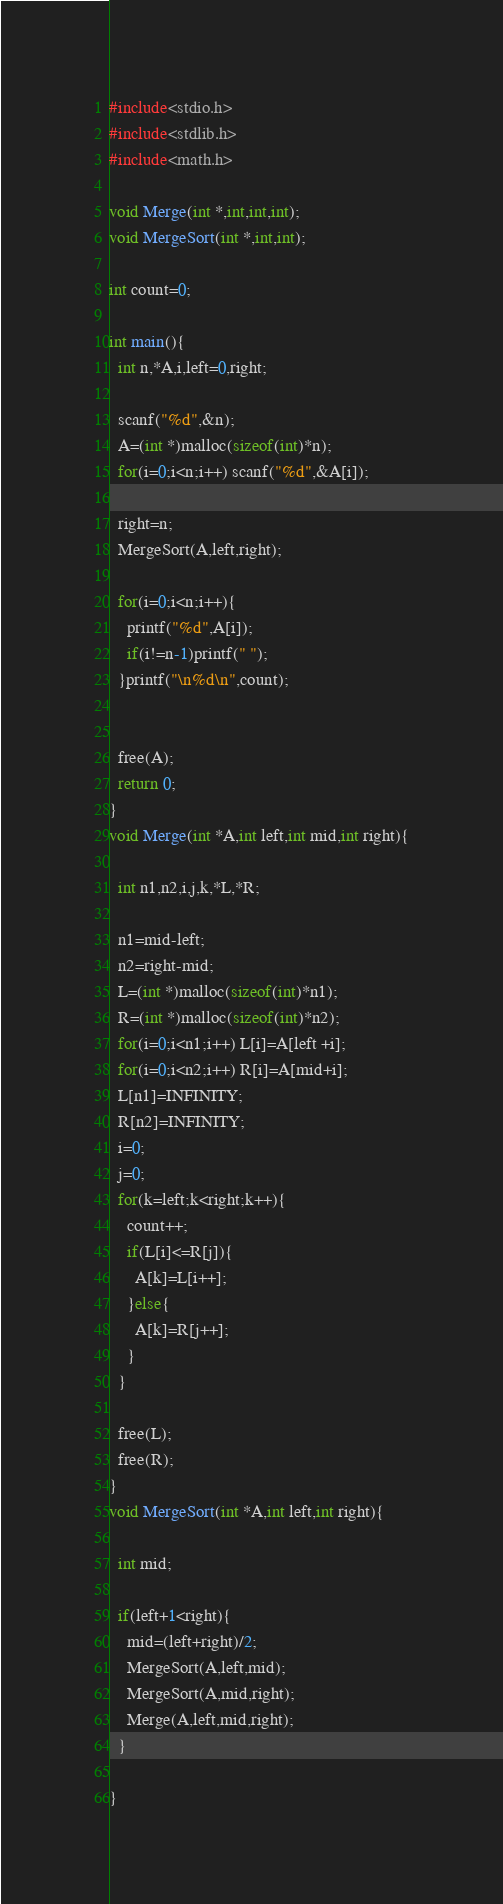Convert code to text. <code><loc_0><loc_0><loc_500><loc_500><_C_>#include<stdio.h>
#include<stdlib.h>
#include<math.h>

void Merge(int *,int,int,int);
void MergeSort(int *,int,int);

int count=0;

int main(){
  int n,*A,i,left=0,right;

  scanf("%d",&n);
  A=(int *)malloc(sizeof(int)*n);
  for(i=0;i<n;i++) scanf("%d",&A[i]);

  right=n;
  MergeSort(A,left,right);

  for(i=0;i<n;i++){
    printf("%d",A[i]);
    if(i!=n-1)printf(" ");
  }printf("\n%d\n",count);


  free(A);
  return 0;
}
void Merge(int *A,int left,int mid,int right){

  int n1,n2,i,j,k,*L,*R;

  n1=mid-left;
  n2=right-mid;
  L=(int *)malloc(sizeof(int)*n1);
  R=(int *)malloc(sizeof(int)*n2);
  for(i=0;i<n1;i++) L[i]=A[left +i];
  for(i=0;i<n2;i++) R[i]=A[mid+i];
  L[n1]=INFINITY;
  R[n2]=INFINITY;
  i=0;
  j=0;
  for(k=left;k<right;k++){
    count++;
    if(L[i]<=R[j]){
      A[k]=L[i++];
    }else{
      A[k]=R[j++];
    }
  }

  free(L);
  free(R);
}
void MergeSort(int *A,int left,int right){

  int mid;

  if(left+1<right){
    mid=(left+right)/2;
    MergeSort(A,left,mid);
    MergeSort(A,mid,right);
    Merge(A,left,mid,right);
  }

}</code> 